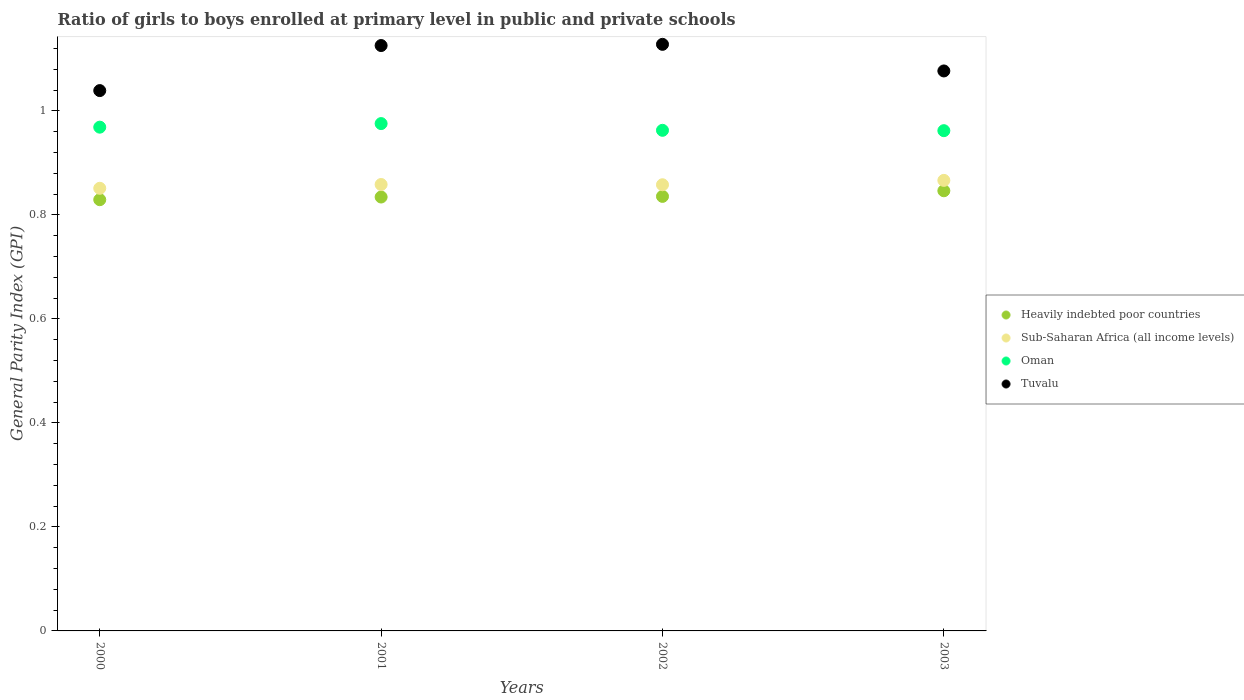What is the general parity index in Oman in 2001?
Offer a very short reply. 0.98. Across all years, what is the maximum general parity index in Sub-Saharan Africa (all income levels)?
Your answer should be compact. 0.87. Across all years, what is the minimum general parity index in Heavily indebted poor countries?
Give a very brief answer. 0.83. In which year was the general parity index in Tuvalu minimum?
Your answer should be very brief. 2000. What is the total general parity index in Sub-Saharan Africa (all income levels) in the graph?
Your answer should be very brief. 3.43. What is the difference between the general parity index in Tuvalu in 2001 and that in 2003?
Provide a short and direct response. 0.05. What is the difference between the general parity index in Oman in 2003 and the general parity index in Heavily indebted poor countries in 2000?
Your answer should be compact. 0.13. What is the average general parity index in Heavily indebted poor countries per year?
Keep it short and to the point. 0.84. In the year 2003, what is the difference between the general parity index in Tuvalu and general parity index in Heavily indebted poor countries?
Keep it short and to the point. 0.23. What is the ratio of the general parity index in Tuvalu in 2000 to that in 2002?
Offer a terse response. 0.92. Is the difference between the general parity index in Tuvalu in 2000 and 2003 greater than the difference between the general parity index in Heavily indebted poor countries in 2000 and 2003?
Your answer should be compact. No. What is the difference between the highest and the second highest general parity index in Tuvalu?
Provide a short and direct response. 0. What is the difference between the highest and the lowest general parity index in Sub-Saharan Africa (all income levels)?
Provide a succinct answer. 0.02. In how many years, is the general parity index in Sub-Saharan Africa (all income levels) greater than the average general parity index in Sub-Saharan Africa (all income levels) taken over all years?
Offer a very short reply. 1. Is it the case that in every year, the sum of the general parity index in Sub-Saharan Africa (all income levels) and general parity index in Heavily indebted poor countries  is greater than the general parity index in Oman?
Ensure brevity in your answer.  Yes. Does the general parity index in Oman monotonically increase over the years?
Offer a terse response. No. Is the general parity index in Heavily indebted poor countries strictly greater than the general parity index in Tuvalu over the years?
Your answer should be very brief. No. How many dotlines are there?
Provide a short and direct response. 4. What is the difference between two consecutive major ticks on the Y-axis?
Offer a terse response. 0.2. Does the graph contain any zero values?
Keep it short and to the point. No. What is the title of the graph?
Make the answer very short. Ratio of girls to boys enrolled at primary level in public and private schools. Does "Panama" appear as one of the legend labels in the graph?
Offer a terse response. No. What is the label or title of the Y-axis?
Keep it short and to the point. General Parity Index (GPI). What is the General Parity Index (GPI) in Heavily indebted poor countries in 2000?
Offer a terse response. 0.83. What is the General Parity Index (GPI) in Sub-Saharan Africa (all income levels) in 2000?
Your answer should be compact. 0.85. What is the General Parity Index (GPI) of Oman in 2000?
Your answer should be compact. 0.97. What is the General Parity Index (GPI) in Tuvalu in 2000?
Keep it short and to the point. 1.04. What is the General Parity Index (GPI) in Heavily indebted poor countries in 2001?
Provide a succinct answer. 0.83. What is the General Parity Index (GPI) in Sub-Saharan Africa (all income levels) in 2001?
Give a very brief answer. 0.86. What is the General Parity Index (GPI) in Oman in 2001?
Provide a succinct answer. 0.98. What is the General Parity Index (GPI) of Tuvalu in 2001?
Offer a very short reply. 1.13. What is the General Parity Index (GPI) in Heavily indebted poor countries in 2002?
Give a very brief answer. 0.84. What is the General Parity Index (GPI) of Sub-Saharan Africa (all income levels) in 2002?
Your answer should be compact. 0.86. What is the General Parity Index (GPI) of Oman in 2002?
Your answer should be very brief. 0.96. What is the General Parity Index (GPI) in Tuvalu in 2002?
Your answer should be very brief. 1.13. What is the General Parity Index (GPI) in Heavily indebted poor countries in 2003?
Keep it short and to the point. 0.85. What is the General Parity Index (GPI) in Sub-Saharan Africa (all income levels) in 2003?
Your response must be concise. 0.87. What is the General Parity Index (GPI) in Oman in 2003?
Provide a short and direct response. 0.96. What is the General Parity Index (GPI) of Tuvalu in 2003?
Provide a succinct answer. 1.08. Across all years, what is the maximum General Parity Index (GPI) of Heavily indebted poor countries?
Provide a succinct answer. 0.85. Across all years, what is the maximum General Parity Index (GPI) of Sub-Saharan Africa (all income levels)?
Your answer should be compact. 0.87. Across all years, what is the maximum General Parity Index (GPI) of Oman?
Provide a short and direct response. 0.98. Across all years, what is the maximum General Parity Index (GPI) in Tuvalu?
Your response must be concise. 1.13. Across all years, what is the minimum General Parity Index (GPI) of Heavily indebted poor countries?
Offer a terse response. 0.83. Across all years, what is the minimum General Parity Index (GPI) of Sub-Saharan Africa (all income levels)?
Keep it short and to the point. 0.85. Across all years, what is the minimum General Parity Index (GPI) in Oman?
Give a very brief answer. 0.96. Across all years, what is the minimum General Parity Index (GPI) in Tuvalu?
Offer a very short reply. 1.04. What is the total General Parity Index (GPI) of Heavily indebted poor countries in the graph?
Ensure brevity in your answer.  3.35. What is the total General Parity Index (GPI) in Sub-Saharan Africa (all income levels) in the graph?
Keep it short and to the point. 3.43. What is the total General Parity Index (GPI) of Oman in the graph?
Give a very brief answer. 3.87. What is the total General Parity Index (GPI) of Tuvalu in the graph?
Offer a terse response. 4.37. What is the difference between the General Parity Index (GPI) of Heavily indebted poor countries in 2000 and that in 2001?
Your response must be concise. -0.01. What is the difference between the General Parity Index (GPI) of Sub-Saharan Africa (all income levels) in 2000 and that in 2001?
Your answer should be very brief. -0.01. What is the difference between the General Parity Index (GPI) in Oman in 2000 and that in 2001?
Offer a very short reply. -0.01. What is the difference between the General Parity Index (GPI) of Tuvalu in 2000 and that in 2001?
Provide a succinct answer. -0.09. What is the difference between the General Parity Index (GPI) of Heavily indebted poor countries in 2000 and that in 2002?
Make the answer very short. -0.01. What is the difference between the General Parity Index (GPI) in Sub-Saharan Africa (all income levels) in 2000 and that in 2002?
Offer a very short reply. -0.01. What is the difference between the General Parity Index (GPI) in Oman in 2000 and that in 2002?
Your answer should be very brief. 0.01. What is the difference between the General Parity Index (GPI) in Tuvalu in 2000 and that in 2002?
Your answer should be very brief. -0.09. What is the difference between the General Parity Index (GPI) of Heavily indebted poor countries in 2000 and that in 2003?
Your answer should be very brief. -0.02. What is the difference between the General Parity Index (GPI) in Sub-Saharan Africa (all income levels) in 2000 and that in 2003?
Offer a very short reply. -0.02. What is the difference between the General Parity Index (GPI) in Oman in 2000 and that in 2003?
Ensure brevity in your answer.  0.01. What is the difference between the General Parity Index (GPI) in Tuvalu in 2000 and that in 2003?
Your answer should be very brief. -0.04. What is the difference between the General Parity Index (GPI) in Heavily indebted poor countries in 2001 and that in 2002?
Your answer should be compact. -0. What is the difference between the General Parity Index (GPI) in Oman in 2001 and that in 2002?
Your response must be concise. 0.01. What is the difference between the General Parity Index (GPI) in Tuvalu in 2001 and that in 2002?
Keep it short and to the point. -0. What is the difference between the General Parity Index (GPI) in Heavily indebted poor countries in 2001 and that in 2003?
Offer a very short reply. -0.01. What is the difference between the General Parity Index (GPI) in Sub-Saharan Africa (all income levels) in 2001 and that in 2003?
Offer a very short reply. -0.01. What is the difference between the General Parity Index (GPI) of Oman in 2001 and that in 2003?
Offer a very short reply. 0.01. What is the difference between the General Parity Index (GPI) in Tuvalu in 2001 and that in 2003?
Your answer should be very brief. 0.05. What is the difference between the General Parity Index (GPI) of Heavily indebted poor countries in 2002 and that in 2003?
Your response must be concise. -0.01. What is the difference between the General Parity Index (GPI) of Sub-Saharan Africa (all income levels) in 2002 and that in 2003?
Give a very brief answer. -0.01. What is the difference between the General Parity Index (GPI) in Oman in 2002 and that in 2003?
Your answer should be very brief. 0. What is the difference between the General Parity Index (GPI) in Tuvalu in 2002 and that in 2003?
Your answer should be compact. 0.05. What is the difference between the General Parity Index (GPI) in Heavily indebted poor countries in 2000 and the General Parity Index (GPI) in Sub-Saharan Africa (all income levels) in 2001?
Your answer should be compact. -0.03. What is the difference between the General Parity Index (GPI) of Heavily indebted poor countries in 2000 and the General Parity Index (GPI) of Oman in 2001?
Your response must be concise. -0.15. What is the difference between the General Parity Index (GPI) of Heavily indebted poor countries in 2000 and the General Parity Index (GPI) of Tuvalu in 2001?
Provide a succinct answer. -0.3. What is the difference between the General Parity Index (GPI) of Sub-Saharan Africa (all income levels) in 2000 and the General Parity Index (GPI) of Oman in 2001?
Your response must be concise. -0.12. What is the difference between the General Parity Index (GPI) of Sub-Saharan Africa (all income levels) in 2000 and the General Parity Index (GPI) of Tuvalu in 2001?
Make the answer very short. -0.27. What is the difference between the General Parity Index (GPI) of Oman in 2000 and the General Parity Index (GPI) of Tuvalu in 2001?
Give a very brief answer. -0.16. What is the difference between the General Parity Index (GPI) of Heavily indebted poor countries in 2000 and the General Parity Index (GPI) of Sub-Saharan Africa (all income levels) in 2002?
Provide a short and direct response. -0.03. What is the difference between the General Parity Index (GPI) in Heavily indebted poor countries in 2000 and the General Parity Index (GPI) in Oman in 2002?
Provide a succinct answer. -0.13. What is the difference between the General Parity Index (GPI) in Heavily indebted poor countries in 2000 and the General Parity Index (GPI) in Tuvalu in 2002?
Your response must be concise. -0.3. What is the difference between the General Parity Index (GPI) in Sub-Saharan Africa (all income levels) in 2000 and the General Parity Index (GPI) in Oman in 2002?
Give a very brief answer. -0.11. What is the difference between the General Parity Index (GPI) of Sub-Saharan Africa (all income levels) in 2000 and the General Parity Index (GPI) of Tuvalu in 2002?
Offer a terse response. -0.28. What is the difference between the General Parity Index (GPI) of Oman in 2000 and the General Parity Index (GPI) of Tuvalu in 2002?
Offer a very short reply. -0.16. What is the difference between the General Parity Index (GPI) in Heavily indebted poor countries in 2000 and the General Parity Index (GPI) in Sub-Saharan Africa (all income levels) in 2003?
Make the answer very short. -0.04. What is the difference between the General Parity Index (GPI) of Heavily indebted poor countries in 2000 and the General Parity Index (GPI) of Oman in 2003?
Your answer should be compact. -0.13. What is the difference between the General Parity Index (GPI) of Heavily indebted poor countries in 2000 and the General Parity Index (GPI) of Tuvalu in 2003?
Give a very brief answer. -0.25. What is the difference between the General Parity Index (GPI) of Sub-Saharan Africa (all income levels) in 2000 and the General Parity Index (GPI) of Oman in 2003?
Make the answer very short. -0.11. What is the difference between the General Parity Index (GPI) in Sub-Saharan Africa (all income levels) in 2000 and the General Parity Index (GPI) in Tuvalu in 2003?
Your answer should be very brief. -0.23. What is the difference between the General Parity Index (GPI) of Oman in 2000 and the General Parity Index (GPI) of Tuvalu in 2003?
Your response must be concise. -0.11. What is the difference between the General Parity Index (GPI) in Heavily indebted poor countries in 2001 and the General Parity Index (GPI) in Sub-Saharan Africa (all income levels) in 2002?
Make the answer very short. -0.02. What is the difference between the General Parity Index (GPI) in Heavily indebted poor countries in 2001 and the General Parity Index (GPI) in Oman in 2002?
Offer a very short reply. -0.13. What is the difference between the General Parity Index (GPI) in Heavily indebted poor countries in 2001 and the General Parity Index (GPI) in Tuvalu in 2002?
Provide a succinct answer. -0.29. What is the difference between the General Parity Index (GPI) in Sub-Saharan Africa (all income levels) in 2001 and the General Parity Index (GPI) in Oman in 2002?
Provide a succinct answer. -0.1. What is the difference between the General Parity Index (GPI) in Sub-Saharan Africa (all income levels) in 2001 and the General Parity Index (GPI) in Tuvalu in 2002?
Offer a very short reply. -0.27. What is the difference between the General Parity Index (GPI) of Oman in 2001 and the General Parity Index (GPI) of Tuvalu in 2002?
Keep it short and to the point. -0.15. What is the difference between the General Parity Index (GPI) of Heavily indebted poor countries in 2001 and the General Parity Index (GPI) of Sub-Saharan Africa (all income levels) in 2003?
Offer a very short reply. -0.03. What is the difference between the General Parity Index (GPI) in Heavily indebted poor countries in 2001 and the General Parity Index (GPI) in Oman in 2003?
Keep it short and to the point. -0.13. What is the difference between the General Parity Index (GPI) in Heavily indebted poor countries in 2001 and the General Parity Index (GPI) in Tuvalu in 2003?
Ensure brevity in your answer.  -0.24. What is the difference between the General Parity Index (GPI) in Sub-Saharan Africa (all income levels) in 2001 and the General Parity Index (GPI) in Oman in 2003?
Make the answer very short. -0.1. What is the difference between the General Parity Index (GPI) in Sub-Saharan Africa (all income levels) in 2001 and the General Parity Index (GPI) in Tuvalu in 2003?
Your response must be concise. -0.22. What is the difference between the General Parity Index (GPI) of Oman in 2001 and the General Parity Index (GPI) of Tuvalu in 2003?
Your answer should be compact. -0.1. What is the difference between the General Parity Index (GPI) of Heavily indebted poor countries in 2002 and the General Parity Index (GPI) of Sub-Saharan Africa (all income levels) in 2003?
Provide a succinct answer. -0.03. What is the difference between the General Parity Index (GPI) of Heavily indebted poor countries in 2002 and the General Parity Index (GPI) of Oman in 2003?
Make the answer very short. -0.13. What is the difference between the General Parity Index (GPI) in Heavily indebted poor countries in 2002 and the General Parity Index (GPI) in Tuvalu in 2003?
Ensure brevity in your answer.  -0.24. What is the difference between the General Parity Index (GPI) in Sub-Saharan Africa (all income levels) in 2002 and the General Parity Index (GPI) in Oman in 2003?
Make the answer very short. -0.1. What is the difference between the General Parity Index (GPI) of Sub-Saharan Africa (all income levels) in 2002 and the General Parity Index (GPI) of Tuvalu in 2003?
Offer a terse response. -0.22. What is the difference between the General Parity Index (GPI) of Oman in 2002 and the General Parity Index (GPI) of Tuvalu in 2003?
Your answer should be compact. -0.11. What is the average General Parity Index (GPI) of Heavily indebted poor countries per year?
Your response must be concise. 0.84. What is the average General Parity Index (GPI) of Sub-Saharan Africa (all income levels) per year?
Provide a short and direct response. 0.86. What is the average General Parity Index (GPI) of Oman per year?
Your response must be concise. 0.97. What is the average General Parity Index (GPI) of Tuvalu per year?
Your answer should be very brief. 1.09. In the year 2000, what is the difference between the General Parity Index (GPI) in Heavily indebted poor countries and General Parity Index (GPI) in Sub-Saharan Africa (all income levels)?
Your answer should be very brief. -0.02. In the year 2000, what is the difference between the General Parity Index (GPI) of Heavily indebted poor countries and General Parity Index (GPI) of Oman?
Offer a very short reply. -0.14. In the year 2000, what is the difference between the General Parity Index (GPI) in Heavily indebted poor countries and General Parity Index (GPI) in Tuvalu?
Keep it short and to the point. -0.21. In the year 2000, what is the difference between the General Parity Index (GPI) of Sub-Saharan Africa (all income levels) and General Parity Index (GPI) of Oman?
Your answer should be compact. -0.12. In the year 2000, what is the difference between the General Parity Index (GPI) of Sub-Saharan Africa (all income levels) and General Parity Index (GPI) of Tuvalu?
Offer a terse response. -0.19. In the year 2000, what is the difference between the General Parity Index (GPI) of Oman and General Parity Index (GPI) of Tuvalu?
Offer a terse response. -0.07. In the year 2001, what is the difference between the General Parity Index (GPI) in Heavily indebted poor countries and General Parity Index (GPI) in Sub-Saharan Africa (all income levels)?
Give a very brief answer. -0.02. In the year 2001, what is the difference between the General Parity Index (GPI) of Heavily indebted poor countries and General Parity Index (GPI) of Oman?
Provide a succinct answer. -0.14. In the year 2001, what is the difference between the General Parity Index (GPI) in Heavily indebted poor countries and General Parity Index (GPI) in Tuvalu?
Your response must be concise. -0.29. In the year 2001, what is the difference between the General Parity Index (GPI) in Sub-Saharan Africa (all income levels) and General Parity Index (GPI) in Oman?
Make the answer very short. -0.12. In the year 2001, what is the difference between the General Parity Index (GPI) of Sub-Saharan Africa (all income levels) and General Parity Index (GPI) of Tuvalu?
Keep it short and to the point. -0.27. In the year 2001, what is the difference between the General Parity Index (GPI) in Oman and General Parity Index (GPI) in Tuvalu?
Ensure brevity in your answer.  -0.15. In the year 2002, what is the difference between the General Parity Index (GPI) in Heavily indebted poor countries and General Parity Index (GPI) in Sub-Saharan Africa (all income levels)?
Ensure brevity in your answer.  -0.02. In the year 2002, what is the difference between the General Parity Index (GPI) in Heavily indebted poor countries and General Parity Index (GPI) in Oman?
Your response must be concise. -0.13. In the year 2002, what is the difference between the General Parity Index (GPI) in Heavily indebted poor countries and General Parity Index (GPI) in Tuvalu?
Make the answer very short. -0.29. In the year 2002, what is the difference between the General Parity Index (GPI) of Sub-Saharan Africa (all income levels) and General Parity Index (GPI) of Oman?
Ensure brevity in your answer.  -0.1. In the year 2002, what is the difference between the General Parity Index (GPI) in Sub-Saharan Africa (all income levels) and General Parity Index (GPI) in Tuvalu?
Give a very brief answer. -0.27. In the year 2002, what is the difference between the General Parity Index (GPI) of Oman and General Parity Index (GPI) of Tuvalu?
Your answer should be very brief. -0.17. In the year 2003, what is the difference between the General Parity Index (GPI) in Heavily indebted poor countries and General Parity Index (GPI) in Sub-Saharan Africa (all income levels)?
Keep it short and to the point. -0.02. In the year 2003, what is the difference between the General Parity Index (GPI) of Heavily indebted poor countries and General Parity Index (GPI) of Oman?
Your response must be concise. -0.12. In the year 2003, what is the difference between the General Parity Index (GPI) of Heavily indebted poor countries and General Parity Index (GPI) of Tuvalu?
Ensure brevity in your answer.  -0.23. In the year 2003, what is the difference between the General Parity Index (GPI) of Sub-Saharan Africa (all income levels) and General Parity Index (GPI) of Oman?
Offer a terse response. -0.1. In the year 2003, what is the difference between the General Parity Index (GPI) in Sub-Saharan Africa (all income levels) and General Parity Index (GPI) in Tuvalu?
Provide a short and direct response. -0.21. In the year 2003, what is the difference between the General Parity Index (GPI) in Oman and General Parity Index (GPI) in Tuvalu?
Keep it short and to the point. -0.11. What is the ratio of the General Parity Index (GPI) of Heavily indebted poor countries in 2000 to that in 2001?
Your response must be concise. 0.99. What is the ratio of the General Parity Index (GPI) of Sub-Saharan Africa (all income levels) in 2000 to that in 2001?
Your response must be concise. 0.99. What is the ratio of the General Parity Index (GPI) in Tuvalu in 2000 to that in 2001?
Keep it short and to the point. 0.92. What is the ratio of the General Parity Index (GPI) in Tuvalu in 2000 to that in 2002?
Offer a terse response. 0.92. What is the ratio of the General Parity Index (GPI) in Heavily indebted poor countries in 2000 to that in 2003?
Keep it short and to the point. 0.98. What is the ratio of the General Parity Index (GPI) in Sub-Saharan Africa (all income levels) in 2000 to that in 2003?
Make the answer very short. 0.98. What is the ratio of the General Parity Index (GPI) in Oman in 2000 to that in 2003?
Keep it short and to the point. 1.01. What is the ratio of the General Parity Index (GPI) of Tuvalu in 2000 to that in 2003?
Your response must be concise. 0.96. What is the ratio of the General Parity Index (GPI) in Heavily indebted poor countries in 2001 to that in 2002?
Provide a succinct answer. 1. What is the ratio of the General Parity Index (GPI) of Oman in 2001 to that in 2002?
Offer a very short reply. 1.01. What is the ratio of the General Parity Index (GPI) of Tuvalu in 2001 to that in 2002?
Your answer should be compact. 1. What is the ratio of the General Parity Index (GPI) of Heavily indebted poor countries in 2001 to that in 2003?
Ensure brevity in your answer.  0.99. What is the ratio of the General Parity Index (GPI) of Oman in 2001 to that in 2003?
Make the answer very short. 1.01. What is the ratio of the General Parity Index (GPI) in Tuvalu in 2001 to that in 2003?
Provide a short and direct response. 1.05. What is the ratio of the General Parity Index (GPI) in Heavily indebted poor countries in 2002 to that in 2003?
Offer a very short reply. 0.99. What is the ratio of the General Parity Index (GPI) in Sub-Saharan Africa (all income levels) in 2002 to that in 2003?
Provide a short and direct response. 0.99. What is the ratio of the General Parity Index (GPI) of Tuvalu in 2002 to that in 2003?
Your answer should be compact. 1.05. What is the difference between the highest and the second highest General Parity Index (GPI) of Heavily indebted poor countries?
Offer a very short reply. 0.01. What is the difference between the highest and the second highest General Parity Index (GPI) in Sub-Saharan Africa (all income levels)?
Provide a succinct answer. 0.01. What is the difference between the highest and the second highest General Parity Index (GPI) in Oman?
Give a very brief answer. 0.01. What is the difference between the highest and the second highest General Parity Index (GPI) of Tuvalu?
Offer a terse response. 0. What is the difference between the highest and the lowest General Parity Index (GPI) of Heavily indebted poor countries?
Your answer should be compact. 0.02. What is the difference between the highest and the lowest General Parity Index (GPI) of Sub-Saharan Africa (all income levels)?
Your answer should be compact. 0.02. What is the difference between the highest and the lowest General Parity Index (GPI) of Oman?
Provide a succinct answer. 0.01. What is the difference between the highest and the lowest General Parity Index (GPI) of Tuvalu?
Keep it short and to the point. 0.09. 